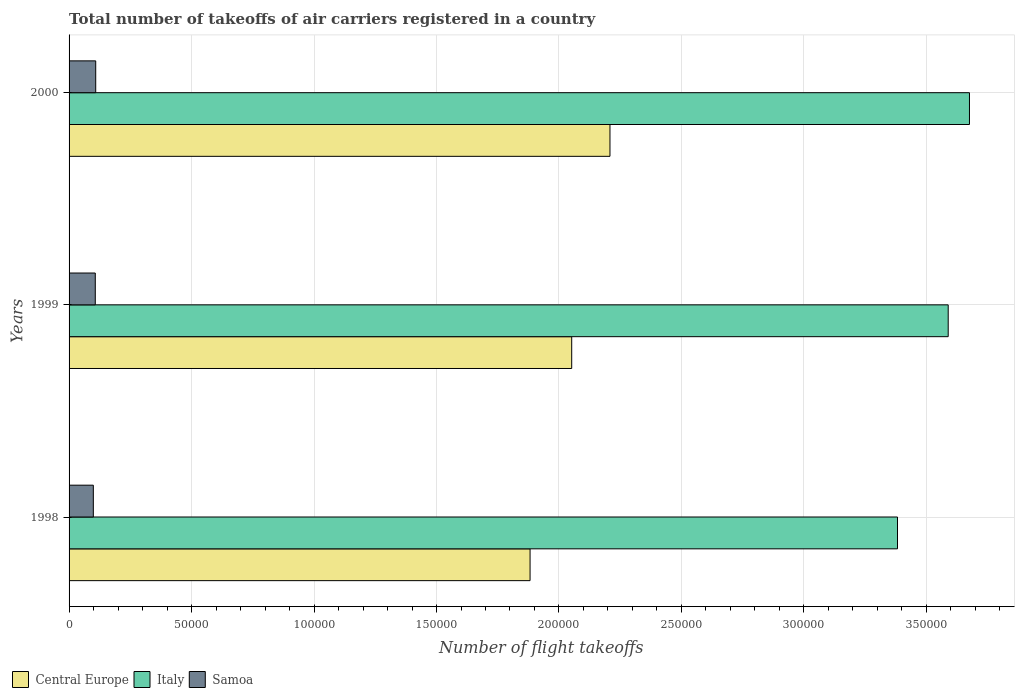How many groups of bars are there?
Provide a succinct answer. 3. How many bars are there on the 3rd tick from the top?
Provide a succinct answer. 3. How many bars are there on the 2nd tick from the bottom?
Your response must be concise. 3. What is the label of the 3rd group of bars from the top?
Your response must be concise. 1998. What is the total number of flight takeoffs in Samoa in 1998?
Offer a terse response. 9900. Across all years, what is the maximum total number of flight takeoffs in Italy?
Offer a very short reply. 3.68e+05. Across all years, what is the minimum total number of flight takeoffs in Samoa?
Your response must be concise. 9900. In which year was the total number of flight takeoffs in Italy maximum?
Ensure brevity in your answer.  2000. What is the total total number of flight takeoffs in Italy in the graph?
Make the answer very short. 1.06e+06. What is the difference between the total number of flight takeoffs in Samoa in 1998 and that in 2000?
Keep it short and to the point. -977. What is the difference between the total number of flight takeoffs in Italy in 1998 and the total number of flight takeoffs in Samoa in 1999?
Make the answer very short. 3.28e+05. What is the average total number of flight takeoffs in Italy per year?
Ensure brevity in your answer.  3.55e+05. In the year 1998, what is the difference between the total number of flight takeoffs in Central Europe and total number of flight takeoffs in Samoa?
Make the answer very short. 1.78e+05. What is the ratio of the total number of flight takeoffs in Italy in 1998 to that in 2000?
Your answer should be very brief. 0.92. Is the difference between the total number of flight takeoffs in Central Europe in 1999 and 2000 greater than the difference between the total number of flight takeoffs in Samoa in 1999 and 2000?
Keep it short and to the point. No. What is the difference between the highest and the second highest total number of flight takeoffs in Italy?
Provide a short and direct response. 8684. What is the difference between the highest and the lowest total number of flight takeoffs in Italy?
Provide a succinct answer. 2.94e+04. What does the 3rd bar from the top in 1999 represents?
Offer a terse response. Central Europe. What does the 1st bar from the bottom in 2000 represents?
Keep it short and to the point. Central Europe. Is it the case that in every year, the sum of the total number of flight takeoffs in Samoa and total number of flight takeoffs in Italy is greater than the total number of flight takeoffs in Central Europe?
Provide a succinct answer. Yes. How many years are there in the graph?
Your response must be concise. 3. Does the graph contain any zero values?
Offer a very short reply. No. Does the graph contain grids?
Give a very brief answer. Yes. What is the title of the graph?
Keep it short and to the point. Total number of takeoffs of air carriers registered in a country. What is the label or title of the X-axis?
Provide a short and direct response. Number of flight takeoffs. What is the label or title of the Y-axis?
Ensure brevity in your answer.  Years. What is the Number of flight takeoffs in Central Europe in 1998?
Your answer should be very brief. 1.88e+05. What is the Number of flight takeoffs of Italy in 1998?
Give a very brief answer. 3.38e+05. What is the Number of flight takeoffs in Samoa in 1998?
Ensure brevity in your answer.  9900. What is the Number of flight takeoffs of Central Europe in 1999?
Offer a very short reply. 2.05e+05. What is the Number of flight takeoffs in Italy in 1999?
Provide a succinct answer. 3.59e+05. What is the Number of flight takeoffs of Samoa in 1999?
Provide a succinct answer. 1.07e+04. What is the Number of flight takeoffs in Central Europe in 2000?
Your answer should be compact. 2.21e+05. What is the Number of flight takeoffs of Italy in 2000?
Offer a terse response. 3.68e+05. What is the Number of flight takeoffs in Samoa in 2000?
Provide a short and direct response. 1.09e+04. Across all years, what is the maximum Number of flight takeoffs of Central Europe?
Keep it short and to the point. 2.21e+05. Across all years, what is the maximum Number of flight takeoffs of Italy?
Your answer should be compact. 3.68e+05. Across all years, what is the maximum Number of flight takeoffs of Samoa?
Your answer should be very brief. 1.09e+04. Across all years, what is the minimum Number of flight takeoffs of Central Europe?
Provide a short and direct response. 1.88e+05. Across all years, what is the minimum Number of flight takeoffs in Italy?
Provide a short and direct response. 3.38e+05. Across all years, what is the minimum Number of flight takeoffs in Samoa?
Provide a succinct answer. 9900. What is the total Number of flight takeoffs of Central Europe in the graph?
Your answer should be very brief. 6.14e+05. What is the total Number of flight takeoffs of Italy in the graph?
Offer a very short reply. 1.06e+06. What is the total Number of flight takeoffs of Samoa in the graph?
Provide a short and direct response. 3.15e+04. What is the difference between the Number of flight takeoffs in Central Europe in 1998 and that in 1999?
Give a very brief answer. -1.70e+04. What is the difference between the Number of flight takeoffs of Italy in 1998 and that in 1999?
Offer a terse response. -2.07e+04. What is the difference between the Number of flight takeoffs in Samoa in 1998 and that in 1999?
Provide a short and direct response. -800. What is the difference between the Number of flight takeoffs in Central Europe in 1998 and that in 2000?
Your response must be concise. -3.26e+04. What is the difference between the Number of flight takeoffs of Italy in 1998 and that in 2000?
Ensure brevity in your answer.  -2.94e+04. What is the difference between the Number of flight takeoffs of Samoa in 1998 and that in 2000?
Give a very brief answer. -977. What is the difference between the Number of flight takeoffs of Central Europe in 1999 and that in 2000?
Ensure brevity in your answer.  -1.56e+04. What is the difference between the Number of flight takeoffs of Italy in 1999 and that in 2000?
Your answer should be compact. -8684. What is the difference between the Number of flight takeoffs of Samoa in 1999 and that in 2000?
Give a very brief answer. -177. What is the difference between the Number of flight takeoffs of Central Europe in 1998 and the Number of flight takeoffs of Italy in 1999?
Your answer should be very brief. -1.71e+05. What is the difference between the Number of flight takeoffs in Central Europe in 1998 and the Number of flight takeoffs in Samoa in 1999?
Give a very brief answer. 1.78e+05. What is the difference between the Number of flight takeoffs of Italy in 1998 and the Number of flight takeoffs of Samoa in 1999?
Offer a very short reply. 3.28e+05. What is the difference between the Number of flight takeoffs of Central Europe in 1998 and the Number of flight takeoffs of Italy in 2000?
Give a very brief answer. -1.79e+05. What is the difference between the Number of flight takeoffs of Central Europe in 1998 and the Number of flight takeoffs of Samoa in 2000?
Your answer should be very brief. 1.77e+05. What is the difference between the Number of flight takeoffs of Italy in 1998 and the Number of flight takeoffs of Samoa in 2000?
Keep it short and to the point. 3.27e+05. What is the difference between the Number of flight takeoffs in Central Europe in 1999 and the Number of flight takeoffs in Italy in 2000?
Provide a succinct answer. -1.62e+05. What is the difference between the Number of flight takeoffs of Central Europe in 1999 and the Number of flight takeoffs of Samoa in 2000?
Give a very brief answer. 1.94e+05. What is the difference between the Number of flight takeoffs of Italy in 1999 and the Number of flight takeoffs of Samoa in 2000?
Your answer should be very brief. 3.48e+05. What is the average Number of flight takeoffs in Central Europe per year?
Keep it short and to the point. 2.05e+05. What is the average Number of flight takeoffs in Italy per year?
Provide a short and direct response. 3.55e+05. What is the average Number of flight takeoffs of Samoa per year?
Your answer should be very brief. 1.05e+04. In the year 1998, what is the difference between the Number of flight takeoffs of Central Europe and Number of flight takeoffs of Italy?
Your response must be concise. -1.50e+05. In the year 1998, what is the difference between the Number of flight takeoffs of Central Europe and Number of flight takeoffs of Samoa?
Your answer should be very brief. 1.78e+05. In the year 1998, what is the difference between the Number of flight takeoffs of Italy and Number of flight takeoffs of Samoa?
Offer a terse response. 3.28e+05. In the year 1999, what is the difference between the Number of flight takeoffs in Central Europe and Number of flight takeoffs in Italy?
Offer a very short reply. -1.54e+05. In the year 1999, what is the difference between the Number of flight takeoffs in Central Europe and Number of flight takeoffs in Samoa?
Offer a terse response. 1.94e+05. In the year 1999, what is the difference between the Number of flight takeoffs of Italy and Number of flight takeoffs of Samoa?
Your answer should be very brief. 3.48e+05. In the year 2000, what is the difference between the Number of flight takeoffs in Central Europe and Number of flight takeoffs in Italy?
Give a very brief answer. -1.47e+05. In the year 2000, what is the difference between the Number of flight takeoffs of Central Europe and Number of flight takeoffs of Samoa?
Your response must be concise. 2.10e+05. In the year 2000, what is the difference between the Number of flight takeoffs of Italy and Number of flight takeoffs of Samoa?
Ensure brevity in your answer.  3.57e+05. What is the ratio of the Number of flight takeoffs in Central Europe in 1998 to that in 1999?
Make the answer very short. 0.92. What is the ratio of the Number of flight takeoffs of Italy in 1998 to that in 1999?
Offer a terse response. 0.94. What is the ratio of the Number of flight takeoffs of Samoa in 1998 to that in 1999?
Keep it short and to the point. 0.93. What is the ratio of the Number of flight takeoffs in Central Europe in 1998 to that in 2000?
Ensure brevity in your answer.  0.85. What is the ratio of the Number of flight takeoffs in Italy in 1998 to that in 2000?
Provide a succinct answer. 0.92. What is the ratio of the Number of flight takeoffs in Samoa in 1998 to that in 2000?
Offer a terse response. 0.91. What is the ratio of the Number of flight takeoffs of Central Europe in 1999 to that in 2000?
Make the answer very short. 0.93. What is the ratio of the Number of flight takeoffs in Italy in 1999 to that in 2000?
Your answer should be compact. 0.98. What is the ratio of the Number of flight takeoffs of Samoa in 1999 to that in 2000?
Provide a short and direct response. 0.98. What is the difference between the highest and the second highest Number of flight takeoffs of Central Europe?
Ensure brevity in your answer.  1.56e+04. What is the difference between the highest and the second highest Number of flight takeoffs in Italy?
Make the answer very short. 8684. What is the difference between the highest and the second highest Number of flight takeoffs in Samoa?
Your answer should be very brief. 177. What is the difference between the highest and the lowest Number of flight takeoffs in Central Europe?
Your answer should be very brief. 3.26e+04. What is the difference between the highest and the lowest Number of flight takeoffs of Italy?
Offer a very short reply. 2.94e+04. What is the difference between the highest and the lowest Number of flight takeoffs of Samoa?
Your answer should be very brief. 977. 